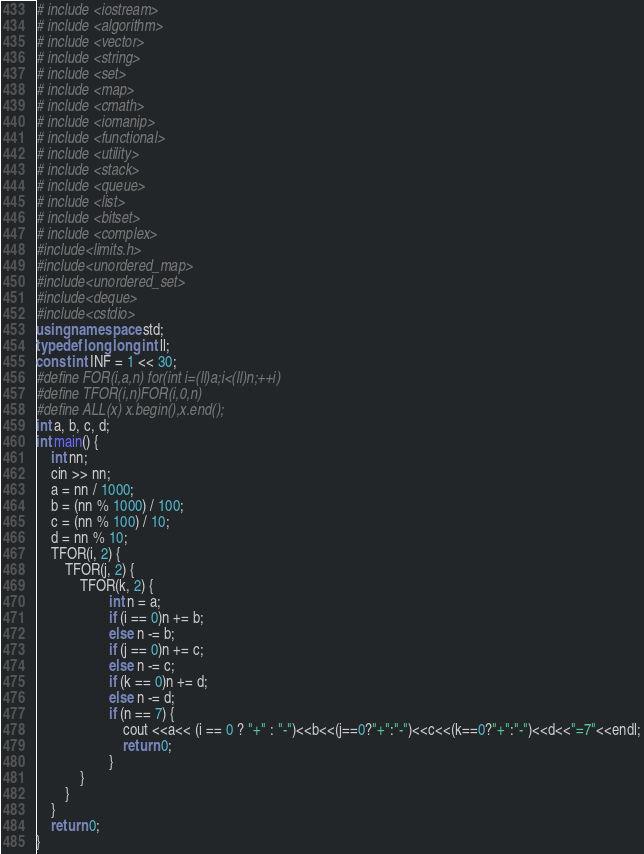Convert code to text. <code><loc_0><loc_0><loc_500><loc_500><_C++_># include <iostream>
# include <algorithm>
# include <vector>
# include <string>
# include <set>
# include <map>
# include <cmath>
# include <iomanip>
# include <functional>
# include <utility>
# include <stack>
# include <queue>
# include <list>
# include <bitset>
# include <complex>
#include<limits.h>
#include<unordered_map>
#include<unordered_set>
#include<deque>
#include<cstdio>
using namespace std;
typedef long long int ll;
const int INF = 1 << 30;
#define FOR(i,a,n) for(int i=(ll)a;i<(ll)n;++i)
#define TFOR(i,n)FOR(i,0,n)
#define ALL(x) x.begin(),x.end();
int a, b, c, d;
int main() {
	int nn;
	cin >> nn;
	a = nn / 1000;
	b = (nn % 1000) / 100;
	c = (nn % 100) / 10;
	d = nn % 10;
	TFOR(i, 2) {
		TFOR(j, 2) {
			TFOR(k, 2) {
					int n = a;
					if (i == 0)n += b;
					else n -= b;
					if (j == 0)n += c;
					else n -= c;
					if (k == 0)n += d;
					else n -= d;
					if (n == 7) {
						cout <<a<< (i == 0 ? "+" : "-")<<b<<(j==0?"+":"-")<<c<<(k==0?"+":"-")<<d<<"=7"<<endl;
						return 0;
					}
			}
		}
	}
	return 0;
}</code> 